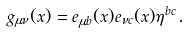<formula> <loc_0><loc_0><loc_500><loc_500>g _ { \mu \nu } ( x ) = e _ { \mu b } ( x ) e _ { \nu c } ( x ) \eta ^ { b c } \, .</formula> 